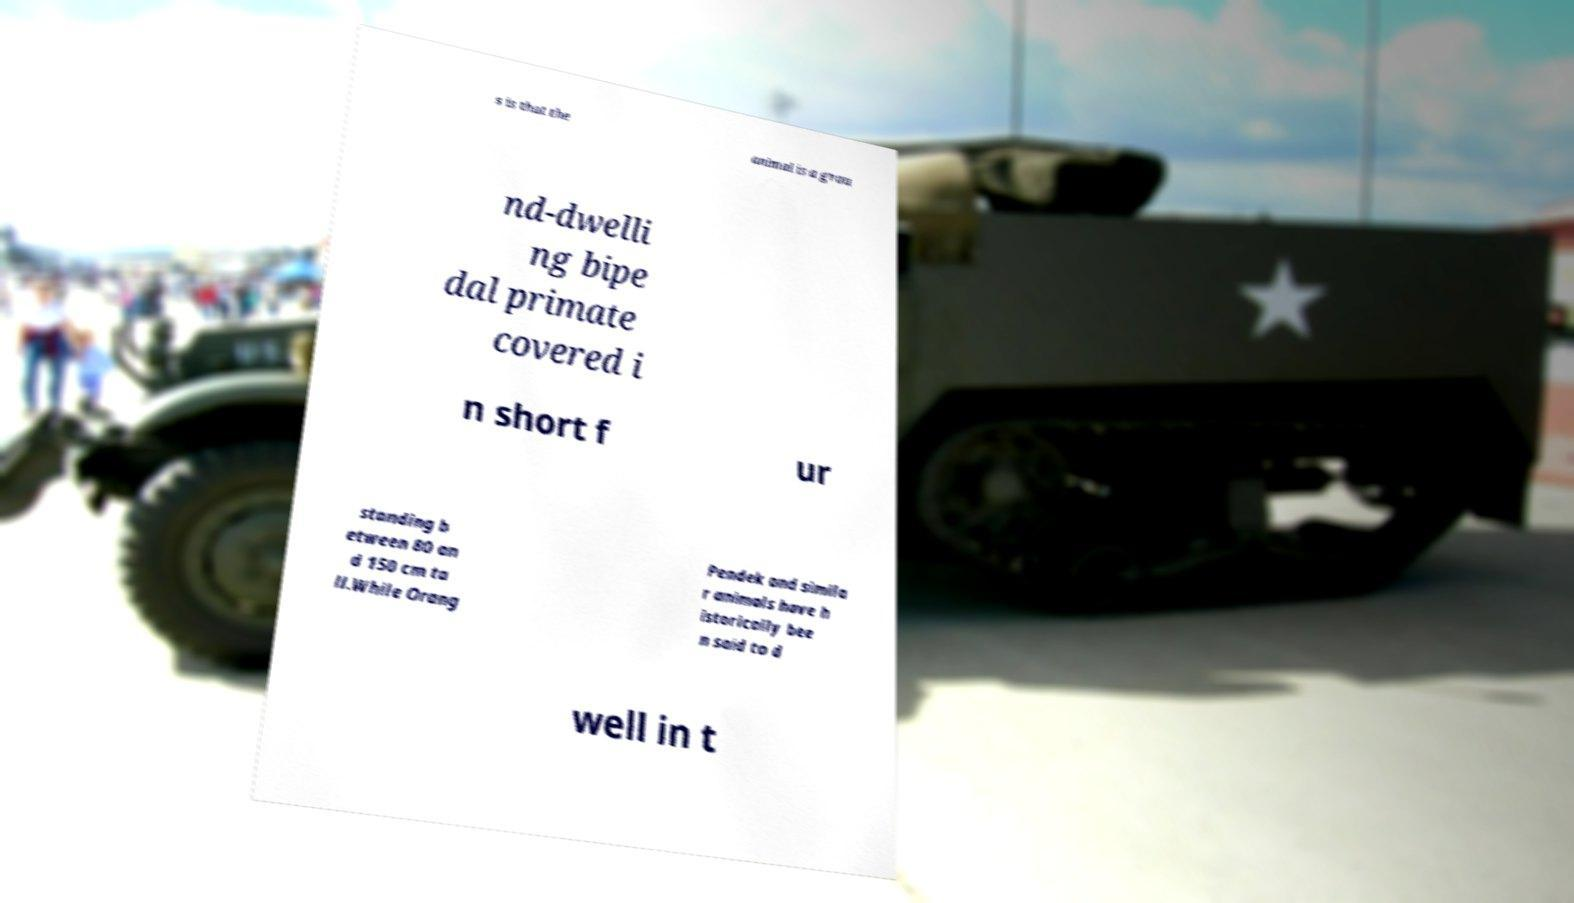Can you accurately transcribe the text from the provided image for me? s is that the animal is a grou nd-dwelli ng bipe dal primate covered i n short f ur standing b etween 80 an d 150 cm ta ll.While Orang Pendek and simila r animals have h istorically bee n said to d well in t 